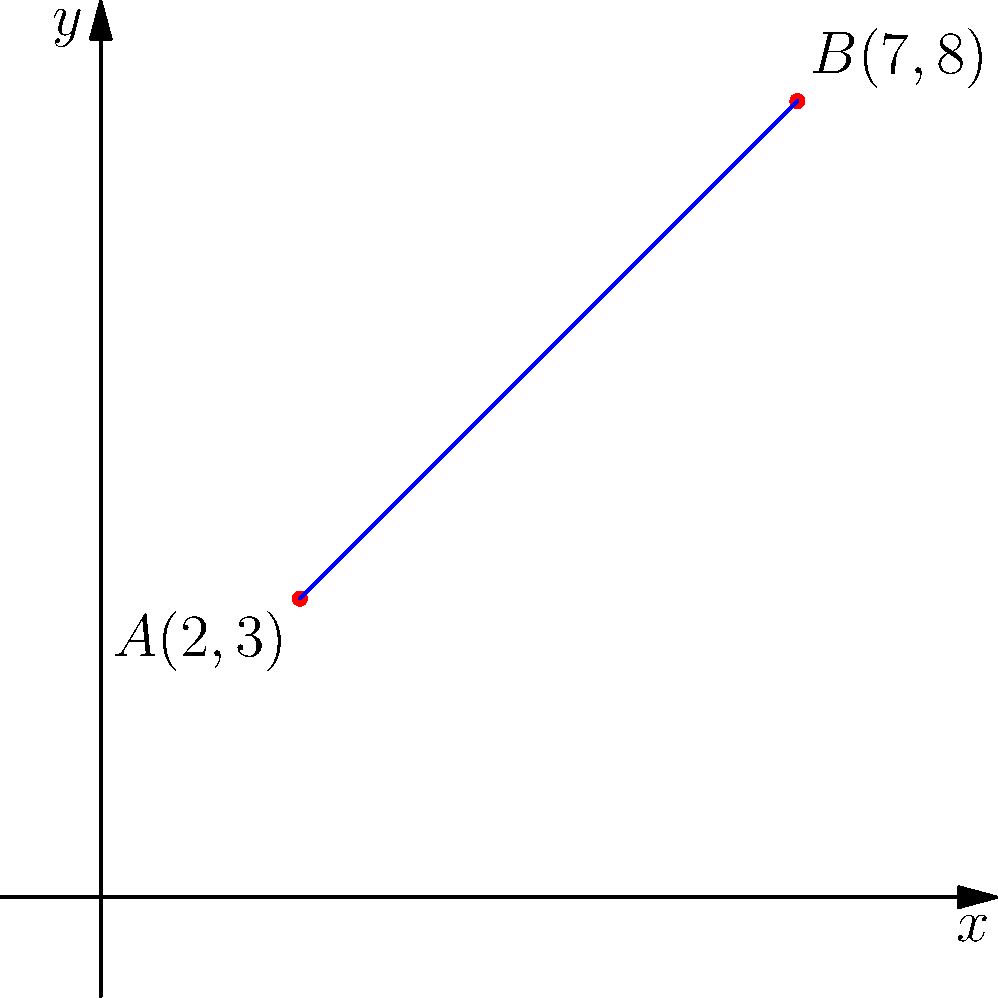As an aspiring interviewer, you're preparing questions about coordinate geometry. Consider two points on a coordinate plane: $A(2,3)$ and $B(7,8)$. Calculate the distance between these two points using the distance formula. Round your answer to two decimal places. To find the distance between two points on a coordinate plane, we use the distance formula:

$d = \sqrt{(x_2-x_1)^2 + (y_2-y_1)^2}$

Where $(x_1,y_1)$ are the coordinates of the first point and $(x_2,y_2)$ are the coordinates of the second point.

Step 1: Identify the coordinates
Point A: $(x_1,y_1) = (2,3)$
Point B: $(x_2,y_2) = (7,8)$

Step 2: Plug the values into the formula
$d = \sqrt{(7-2)^2 + (8-3)^2}$

Step 3: Simplify inside the parentheses
$d = \sqrt{5^2 + 5^2}$

Step 4: Calculate the squares
$d = \sqrt{25 + 25}$

Step 5: Add under the square root
$d = \sqrt{50}$

Step 6: Simplify the square root
$d = 5\sqrt{2} \approx 7.07$

Step 7: Round to two decimal places
$d \approx 7.07$

Therefore, the distance between points A and B is approximately 7.07 units.
Answer: 7.07 units 